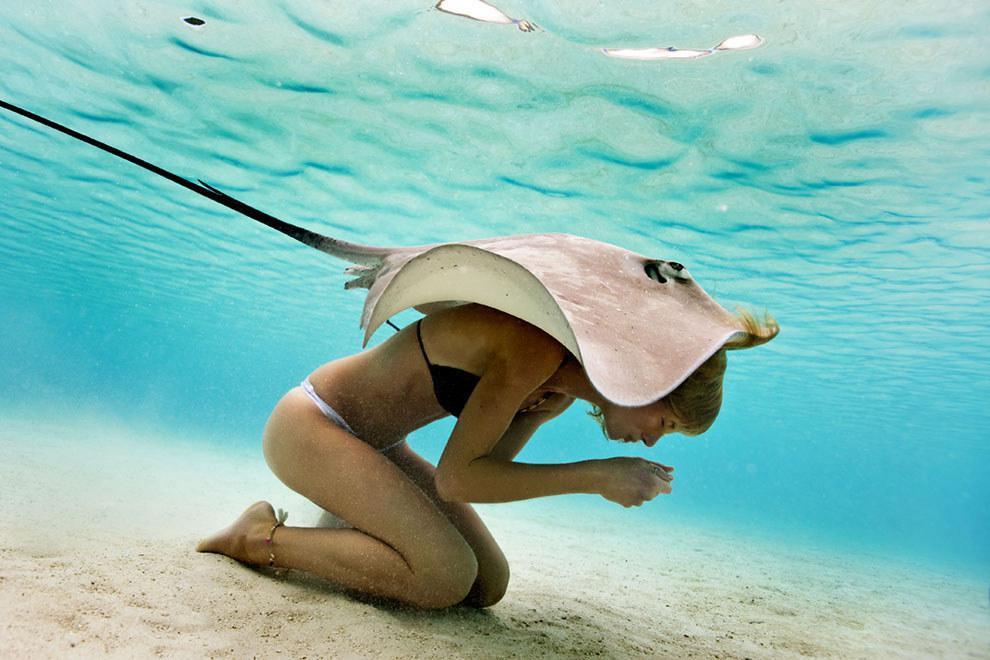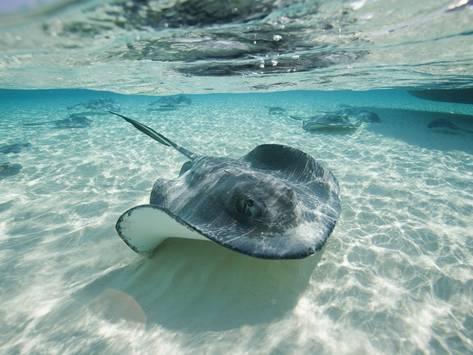The first image is the image on the left, the second image is the image on the right. Analyze the images presented: Is the assertion "Each image is a top-view of a stingray swimming close to the bottom of the ocean." valid? Answer yes or no. No. 